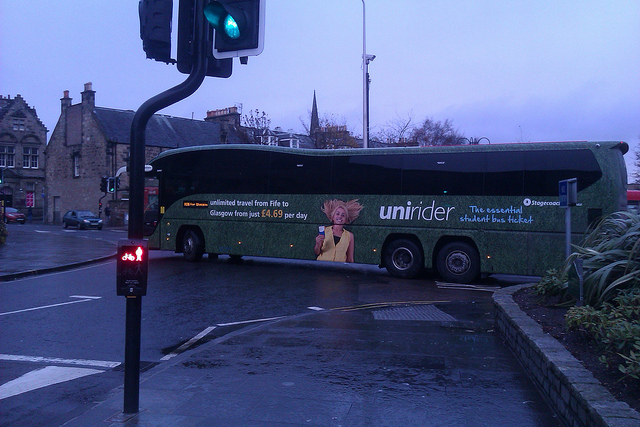What kind of maintenance might the bus require to remain in serviceable condition in such weather? In such damp and rainy conditions, the bus would need regular maintenance to stay operational. This includes routine checks of the windshield wipers, ensuring that the tires have good tread for slippery roads, and checking the brakes regularly for optimal performance. Additionally, the bus should undergo frequent cleaning to prevent mud and grime build-up, particularly in the undercarriage. Anticorrosion treatments could help protect against rust due to moisture exposure. What might be some daily challenges that a bus driver faces in this environment? A bus driver's daily challenges in this environment might include navigating wet, slippery roads with reduced traction, ensuring visibility with frequent wiper use, and dealing with low light conditions on overcast days. They must also be vigilant about pedestrians who may dart to avoid the rain, and manage the increased stopping distance required in wet conditions. Managing timely pickups amid weather-related slowdowns is another key challenge. 